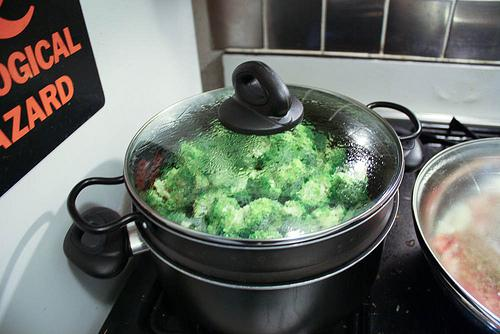Question: how many pots are there?
Choices:
A. 1.
B. 3.
C. 2.
D. 4.
Answer with the letter. Answer: C Question: where was the picture taken?
Choices:
A. In a kitchen.
B. On a mountain.
C. In a car.
D. At the zoo.
Answer with the letter. Answer: A 